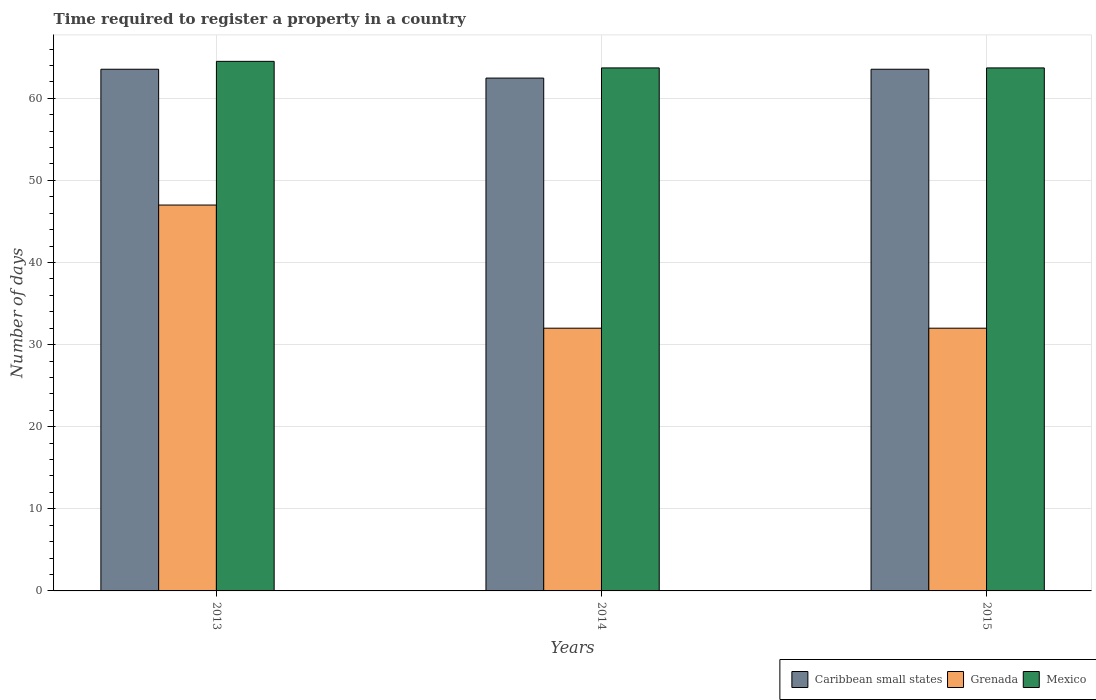How many different coloured bars are there?
Offer a terse response. 3. Are the number of bars per tick equal to the number of legend labels?
Keep it short and to the point. Yes. Are the number of bars on each tick of the X-axis equal?
Make the answer very short. Yes. How many bars are there on the 2nd tick from the right?
Your response must be concise. 3. What is the label of the 3rd group of bars from the left?
Ensure brevity in your answer.  2015. What is the number of days required to register a property in Mexico in 2015?
Your response must be concise. 63.7. Across all years, what is the maximum number of days required to register a property in Grenada?
Make the answer very short. 47. In which year was the number of days required to register a property in Grenada minimum?
Offer a very short reply. 2014. What is the total number of days required to register a property in Caribbean small states in the graph?
Offer a very short reply. 189.54. What is the difference between the number of days required to register a property in Grenada in 2013 and that in 2015?
Your response must be concise. 15. What is the difference between the number of days required to register a property in Caribbean small states in 2015 and the number of days required to register a property in Grenada in 2013?
Offer a terse response. 16.54. What is the average number of days required to register a property in Mexico per year?
Ensure brevity in your answer.  63.97. In the year 2015, what is the difference between the number of days required to register a property in Mexico and number of days required to register a property in Caribbean small states?
Your answer should be very brief. 0.16. What is the ratio of the number of days required to register a property in Mexico in 2013 to that in 2014?
Your answer should be compact. 1.01. What is the difference between the highest and the second highest number of days required to register a property in Caribbean small states?
Your answer should be compact. 0. What is the difference between the highest and the lowest number of days required to register a property in Caribbean small states?
Provide a succinct answer. 1.08. In how many years, is the number of days required to register a property in Caribbean small states greater than the average number of days required to register a property in Caribbean small states taken over all years?
Provide a short and direct response. 2. Is the sum of the number of days required to register a property in Caribbean small states in 2013 and 2015 greater than the maximum number of days required to register a property in Grenada across all years?
Offer a very short reply. Yes. What does the 3rd bar from the left in 2014 represents?
Your response must be concise. Mexico. What does the 1st bar from the right in 2015 represents?
Ensure brevity in your answer.  Mexico. How many years are there in the graph?
Offer a very short reply. 3. Does the graph contain any zero values?
Your answer should be compact. No. Where does the legend appear in the graph?
Offer a terse response. Bottom right. What is the title of the graph?
Give a very brief answer. Time required to register a property in a country. What is the label or title of the Y-axis?
Your response must be concise. Number of days. What is the Number of days in Caribbean small states in 2013?
Provide a short and direct response. 63.54. What is the Number of days in Grenada in 2013?
Your answer should be very brief. 47. What is the Number of days of Mexico in 2013?
Offer a terse response. 64.5. What is the Number of days in Caribbean small states in 2014?
Offer a terse response. 62.46. What is the Number of days in Grenada in 2014?
Keep it short and to the point. 32. What is the Number of days in Mexico in 2014?
Give a very brief answer. 63.7. What is the Number of days of Caribbean small states in 2015?
Your response must be concise. 63.54. What is the Number of days of Mexico in 2015?
Keep it short and to the point. 63.7. Across all years, what is the maximum Number of days in Caribbean small states?
Make the answer very short. 63.54. Across all years, what is the maximum Number of days of Mexico?
Your response must be concise. 64.5. Across all years, what is the minimum Number of days of Caribbean small states?
Give a very brief answer. 62.46. Across all years, what is the minimum Number of days of Mexico?
Provide a succinct answer. 63.7. What is the total Number of days of Caribbean small states in the graph?
Offer a very short reply. 189.54. What is the total Number of days of Grenada in the graph?
Your answer should be compact. 111. What is the total Number of days in Mexico in the graph?
Provide a short and direct response. 191.9. What is the difference between the Number of days of Caribbean small states in 2013 and that in 2014?
Your response must be concise. 1.08. What is the difference between the Number of days in Mexico in 2013 and that in 2014?
Offer a very short reply. 0.8. What is the difference between the Number of days of Grenada in 2013 and that in 2015?
Your answer should be very brief. 15. What is the difference between the Number of days in Caribbean small states in 2014 and that in 2015?
Give a very brief answer. -1.08. What is the difference between the Number of days in Grenada in 2014 and that in 2015?
Give a very brief answer. 0. What is the difference between the Number of days in Caribbean small states in 2013 and the Number of days in Grenada in 2014?
Your response must be concise. 31.54. What is the difference between the Number of days in Caribbean small states in 2013 and the Number of days in Mexico in 2014?
Your response must be concise. -0.16. What is the difference between the Number of days of Grenada in 2013 and the Number of days of Mexico in 2014?
Ensure brevity in your answer.  -16.7. What is the difference between the Number of days in Caribbean small states in 2013 and the Number of days in Grenada in 2015?
Your answer should be compact. 31.54. What is the difference between the Number of days in Caribbean small states in 2013 and the Number of days in Mexico in 2015?
Offer a terse response. -0.16. What is the difference between the Number of days in Grenada in 2013 and the Number of days in Mexico in 2015?
Ensure brevity in your answer.  -16.7. What is the difference between the Number of days in Caribbean small states in 2014 and the Number of days in Grenada in 2015?
Your answer should be compact. 30.46. What is the difference between the Number of days in Caribbean small states in 2014 and the Number of days in Mexico in 2015?
Give a very brief answer. -1.24. What is the difference between the Number of days of Grenada in 2014 and the Number of days of Mexico in 2015?
Provide a succinct answer. -31.7. What is the average Number of days of Caribbean small states per year?
Make the answer very short. 63.18. What is the average Number of days in Grenada per year?
Keep it short and to the point. 37. What is the average Number of days of Mexico per year?
Your response must be concise. 63.97. In the year 2013, what is the difference between the Number of days of Caribbean small states and Number of days of Grenada?
Provide a short and direct response. 16.54. In the year 2013, what is the difference between the Number of days of Caribbean small states and Number of days of Mexico?
Keep it short and to the point. -0.96. In the year 2013, what is the difference between the Number of days of Grenada and Number of days of Mexico?
Make the answer very short. -17.5. In the year 2014, what is the difference between the Number of days in Caribbean small states and Number of days in Grenada?
Give a very brief answer. 30.46. In the year 2014, what is the difference between the Number of days of Caribbean small states and Number of days of Mexico?
Your response must be concise. -1.24. In the year 2014, what is the difference between the Number of days in Grenada and Number of days in Mexico?
Keep it short and to the point. -31.7. In the year 2015, what is the difference between the Number of days of Caribbean small states and Number of days of Grenada?
Keep it short and to the point. 31.54. In the year 2015, what is the difference between the Number of days in Caribbean small states and Number of days in Mexico?
Keep it short and to the point. -0.16. In the year 2015, what is the difference between the Number of days in Grenada and Number of days in Mexico?
Keep it short and to the point. -31.7. What is the ratio of the Number of days in Caribbean small states in 2013 to that in 2014?
Ensure brevity in your answer.  1.02. What is the ratio of the Number of days in Grenada in 2013 to that in 2014?
Give a very brief answer. 1.47. What is the ratio of the Number of days of Mexico in 2013 to that in 2014?
Offer a terse response. 1.01. What is the ratio of the Number of days in Caribbean small states in 2013 to that in 2015?
Offer a very short reply. 1. What is the ratio of the Number of days of Grenada in 2013 to that in 2015?
Give a very brief answer. 1.47. What is the ratio of the Number of days of Mexico in 2013 to that in 2015?
Make the answer very short. 1.01. What is the ratio of the Number of days of Caribbean small states in 2014 to that in 2015?
Make the answer very short. 0.98. What is the ratio of the Number of days of Mexico in 2014 to that in 2015?
Ensure brevity in your answer.  1. What is the difference between the highest and the lowest Number of days of Mexico?
Your answer should be compact. 0.8. 